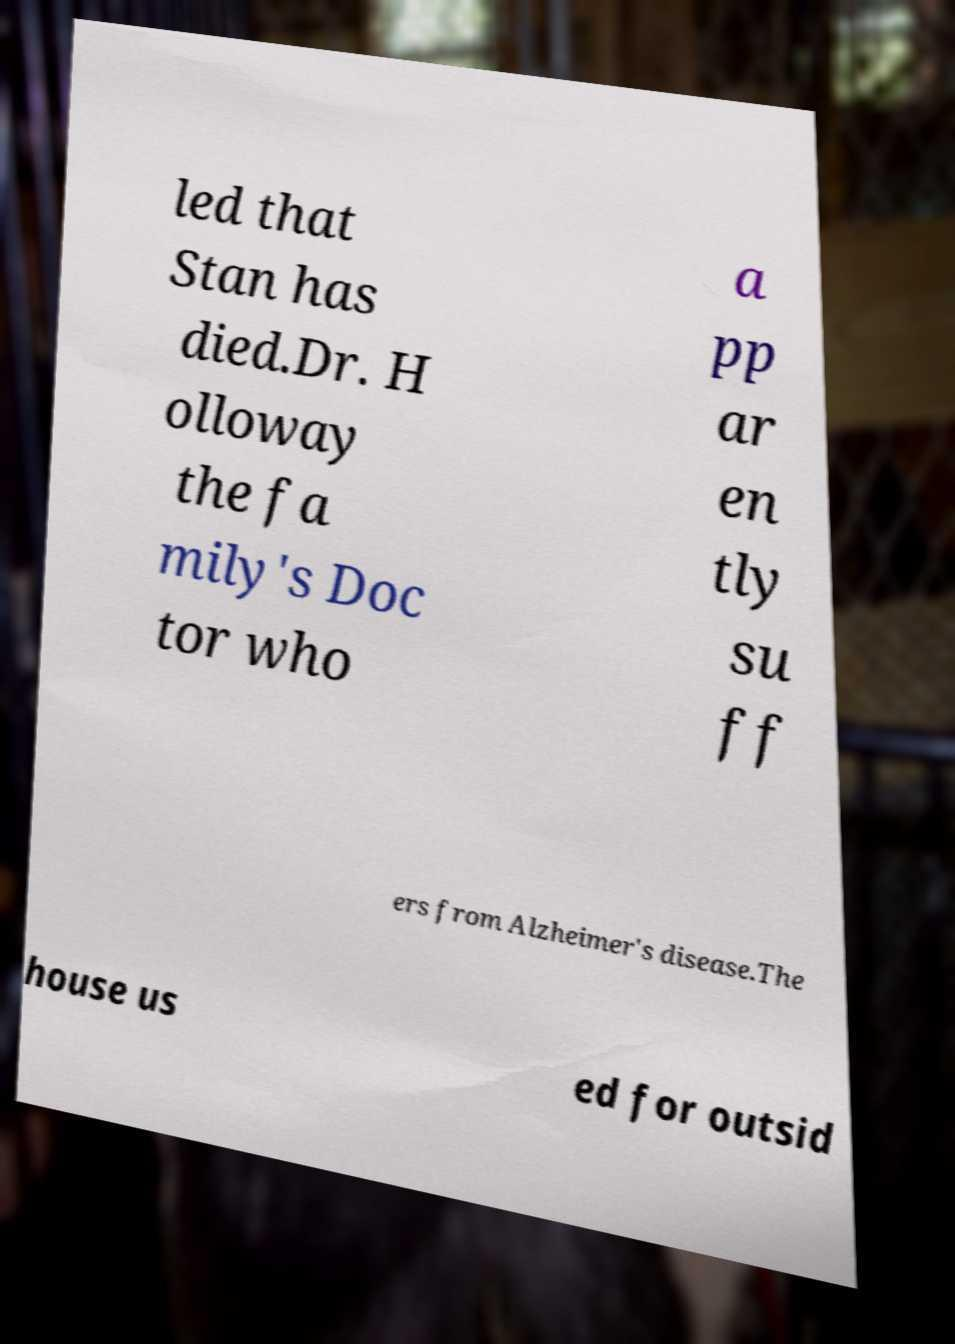Please identify and transcribe the text found in this image. led that Stan has died.Dr. H olloway the fa mily's Doc tor who a pp ar en tly su ff ers from Alzheimer's disease.The house us ed for outsid 